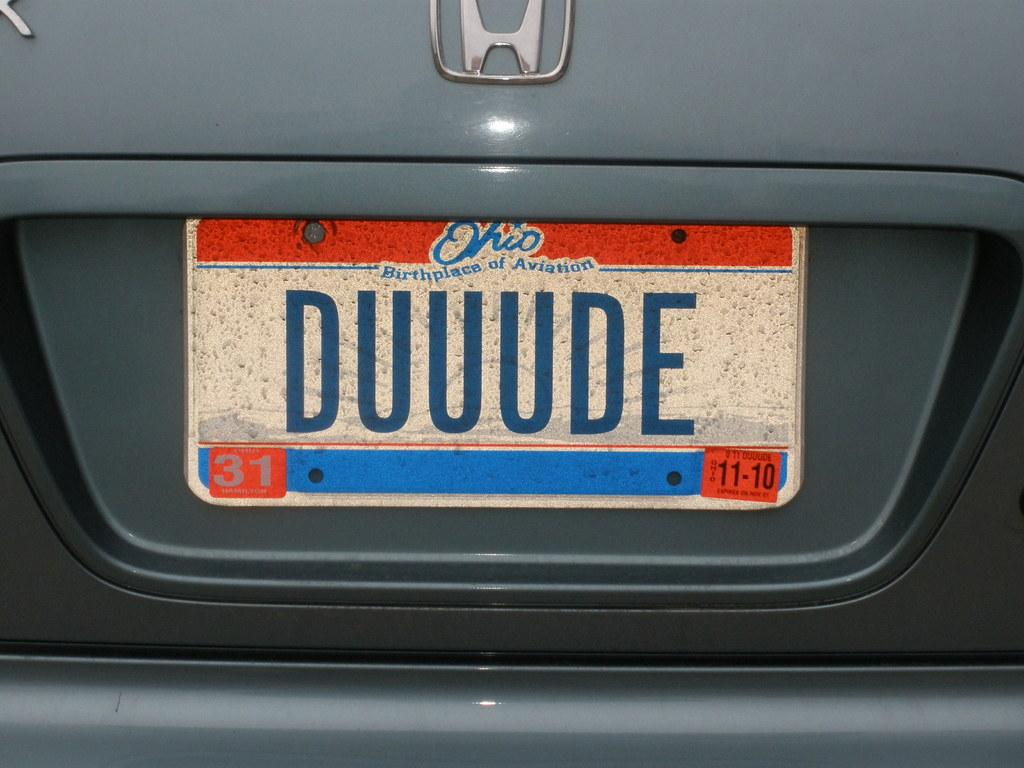<image>
Present a compact description of the photo's key features. An Ohio plate number DUUUDE is on the back of a honda. 